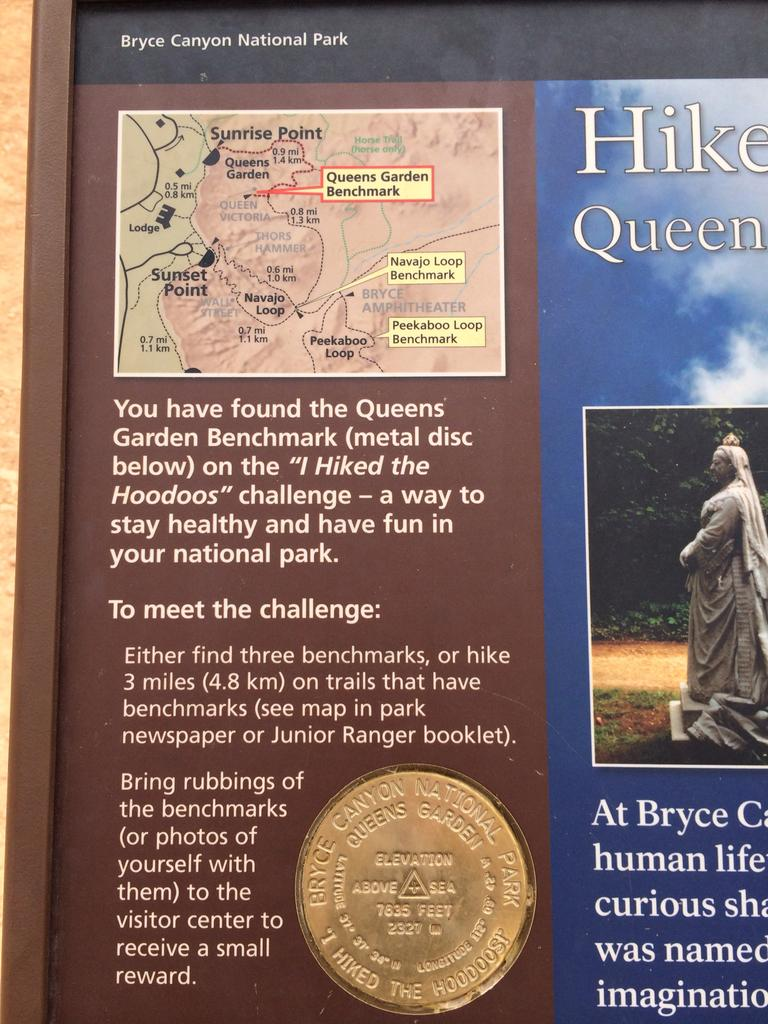<image>
Render a clear and concise summary of the photo. a page describing how to neet the challenge of the queens garden quest 